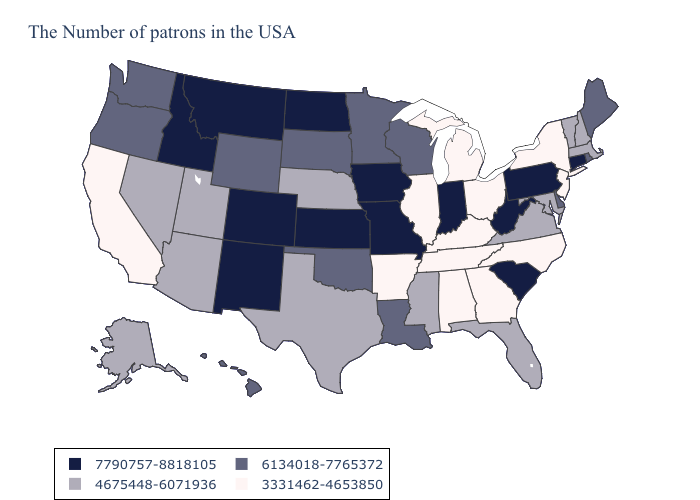What is the highest value in the Northeast ?
Keep it brief. 7790757-8818105. Name the states that have a value in the range 3331462-4653850?
Answer briefly. New York, New Jersey, North Carolina, Ohio, Georgia, Michigan, Kentucky, Alabama, Tennessee, Illinois, Arkansas, California. Does Illinois have a lower value than Wyoming?
Give a very brief answer. Yes. Among the states that border North Dakota , does South Dakota have the lowest value?
Give a very brief answer. Yes. What is the value of Kansas?
Concise answer only. 7790757-8818105. What is the value of Utah?
Give a very brief answer. 4675448-6071936. What is the value of Florida?
Short answer required. 4675448-6071936. Does the map have missing data?
Short answer required. No. Which states have the lowest value in the MidWest?
Quick response, please. Ohio, Michigan, Illinois. What is the highest value in the Northeast ?
Answer briefly. 7790757-8818105. Name the states that have a value in the range 7790757-8818105?
Keep it brief. Connecticut, Pennsylvania, South Carolina, West Virginia, Indiana, Missouri, Iowa, Kansas, North Dakota, Colorado, New Mexico, Montana, Idaho. Does South Carolina have the highest value in the USA?
Give a very brief answer. Yes. Is the legend a continuous bar?
Write a very short answer. No. What is the value of Louisiana?
Answer briefly. 6134018-7765372. What is the lowest value in states that border Minnesota?
Answer briefly. 6134018-7765372. 